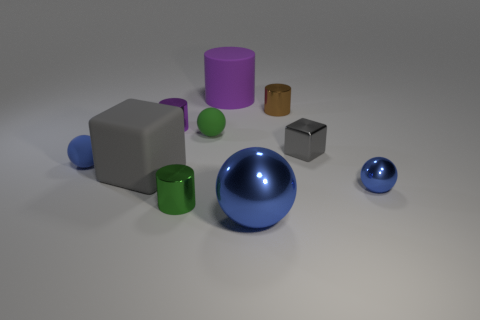Subtract all brown blocks. Subtract all green cylinders. How many blocks are left? 2 Subtract all gray blocks. How many blue cylinders are left? 0 Add 10 purples. How many grays exist? 0 Subtract all big purple cylinders. Subtract all large purple cylinders. How many objects are left? 8 Add 6 large purple rubber cylinders. How many large purple rubber cylinders are left? 7 Add 6 large metal objects. How many large metal objects exist? 7 Subtract all green cylinders. How many cylinders are left? 3 Subtract all green cylinders. How many cylinders are left? 3 Subtract 0 red spheres. How many objects are left? 10 Subtract all purple cylinders. How many were subtracted if there are1purple cylinders left? 1 